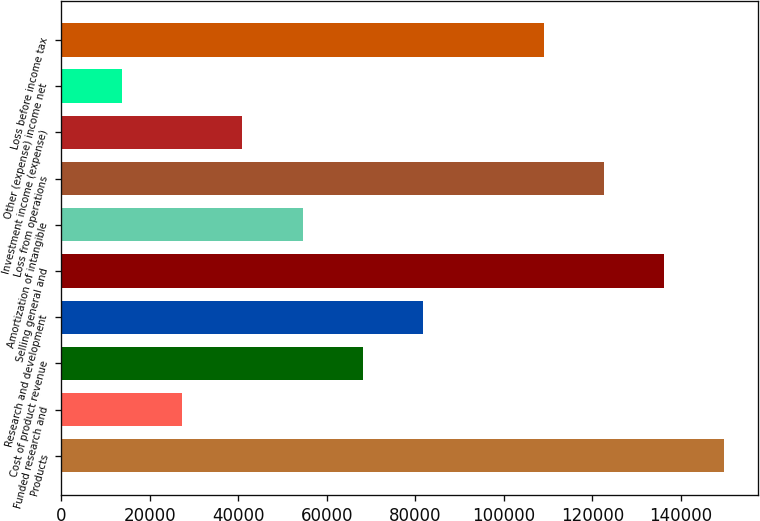Convert chart to OTSL. <chart><loc_0><loc_0><loc_500><loc_500><bar_chart><fcel>Products<fcel>Funded research and<fcel>Cost of product revenue<fcel>Research and development<fcel>Selling general and<fcel>Amortization of intangible<fcel>Loss from operations<fcel>Investment income (expense)<fcel>Other (expense) income net<fcel>Loss before income tax<nl><fcel>149801<fcel>27237.4<fcel>68092<fcel>81710.2<fcel>136183<fcel>54473.8<fcel>122565<fcel>40855.6<fcel>13619.2<fcel>108947<nl></chart> 